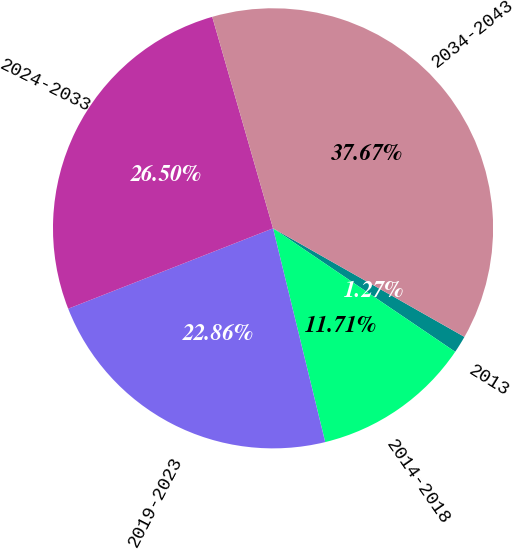Convert chart to OTSL. <chart><loc_0><loc_0><loc_500><loc_500><pie_chart><fcel>2013<fcel>2014-2018<fcel>2019-2023<fcel>2024-2033<fcel>2034-2043<nl><fcel>1.27%<fcel>11.71%<fcel>22.86%<fcel>26.5%<fcel>37.67%<nl></chart> 